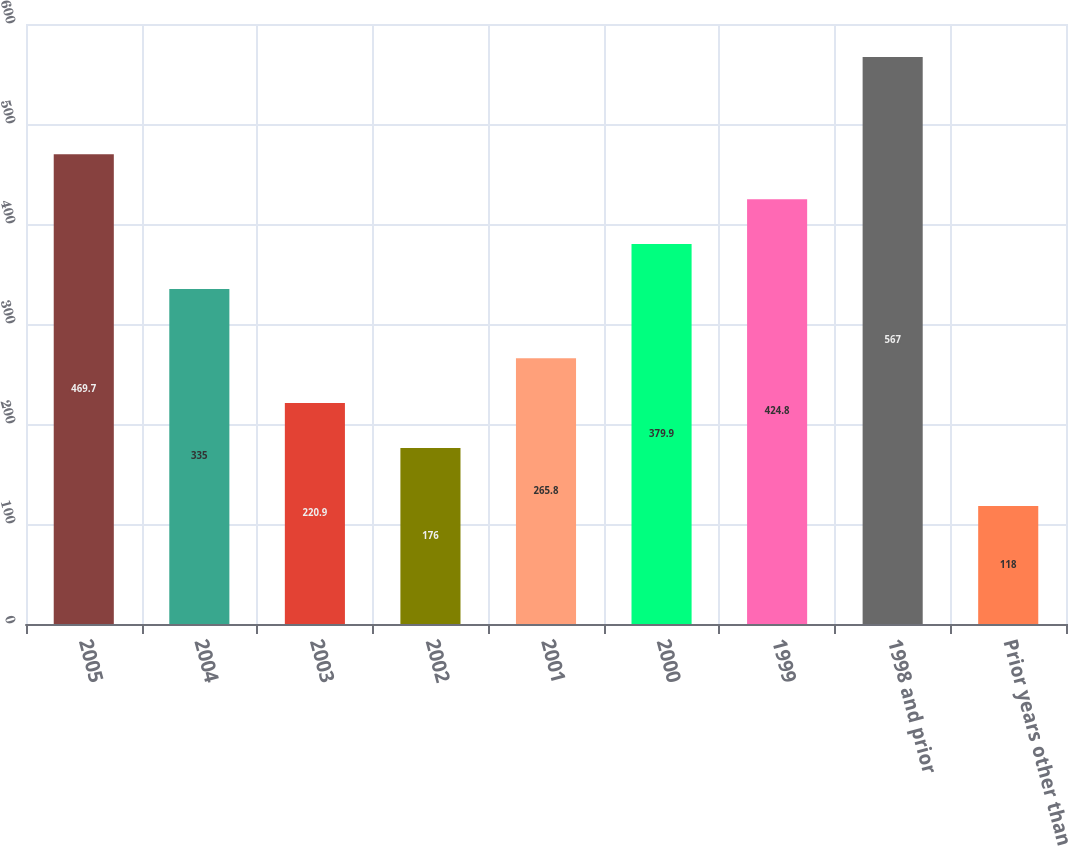<chart> <loc_0><loc_0><loc_500><loc_500><bar_chart><fcel>2005<fcel>2004<fcel>2003<fcel>2002<fcel>2001<fcel>2000<fcel>1999<fcel>1998 and prior<fcel>Prior years other than<nl><fcel>469.7<fcel>335<fcel>220.9<fcel>176<fcel>265.8<fcel>379.9<fcel>424.8<fcel>567<fcel>118<nl></chart> 